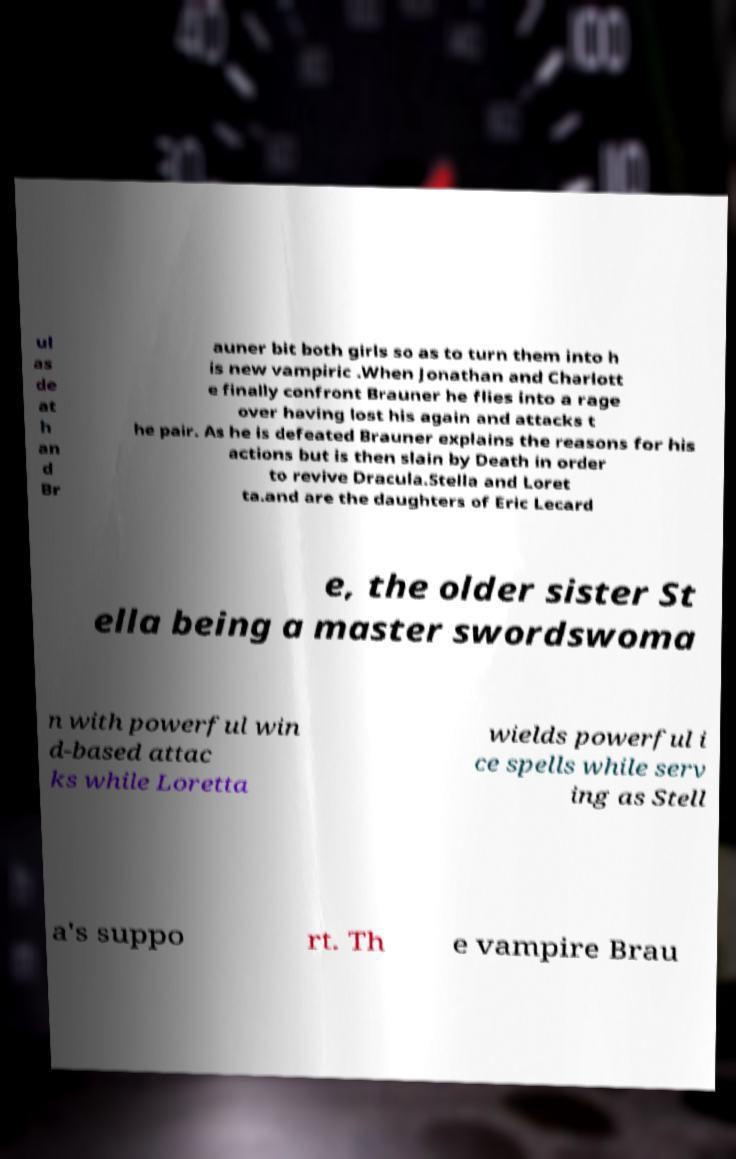What messages or text are displayed in this image? I need them in a readable, typed format. ul as de at h an d Br auner bit both girls so as to turn them into h is new vampiric .When Jonathan and Charlott e finally confront Brauner he flies into a rage over having lost his again and attacks t he pair. As he is defeated Brauner explains the reasons for his actions but is then slain by Death in order to revive Dracula.Stella and Loret ta.and are the daughters of Eric Lecard e, the older sister St ella being a master swordswoma n with powerful win d-based attac ks while Loretta wields powerful i ce spells while serv ing as Stell a's suppo rt. Th e vampire Brau 